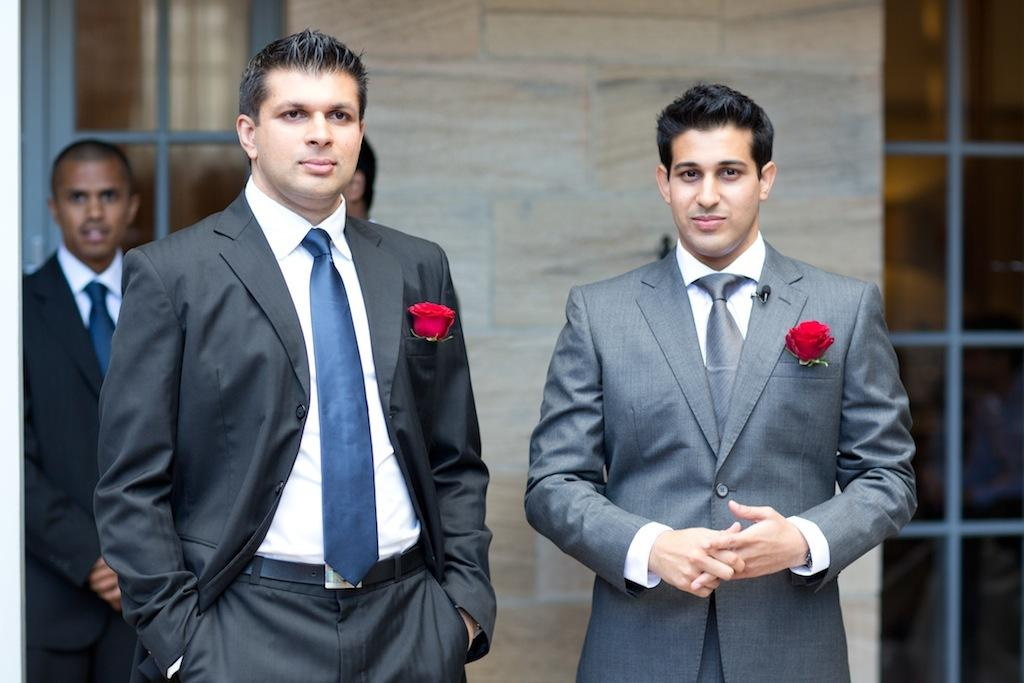What is happening in the image? There are people standing in the image. How can you describe the appearance of the people? The people are wearing different color dresses. What can be seen in the background of the image? There is a building visible in the background. What feature of the building is mentioned in the facts? There are windows on the building. What type of blade is being used by the people in the image? There is no blade present in the image; the people are simply standing. How are the people sorting items in the image? The facts do not mention any sorting activity in the image; the people are just wearing different color dresses. 